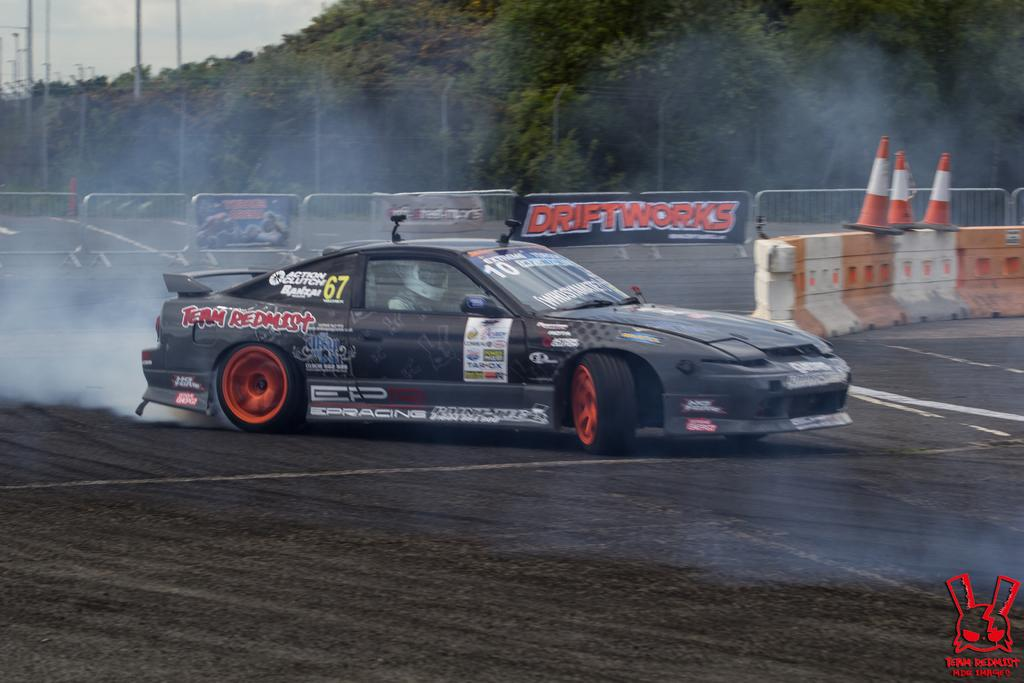What is on the road in the image? There is a vehicle on the road in the image. What else can be seen in the image besides the vehicle? There are banners and fencing visible in the image. What is in the background of the image? There are trees in the background of the image. Where is the calculator located in the image? There is no calculator present in the image. Is there a crown visible on the vehicle in the image? There is no crown visible on the vehicle in the image. 